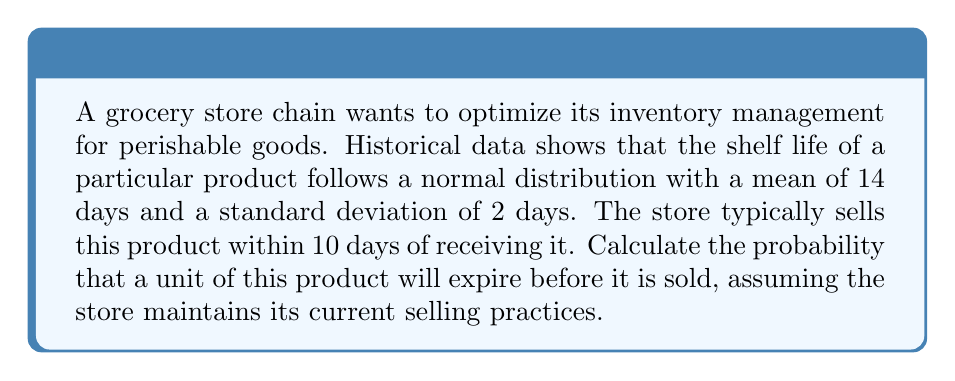Help me with this question. Let's approach this step-by-step:

1) Let X be the random variable representing the shelf life of the product in days.
   X ~ N(μ = 14, σ = 2)

2) We need to find P(X ≤ 10), the probability that the shelf life is 10 days or less.

3) To do this, we need to calculate the z-score for 10 days:

   $$ z = \frac{x - \mu}{\sigma} = \frac{10 - 14}{2} = -2 $$

4) Now we need to find the probability that Z ≤ -2 using the standard normal distribution table.

5) From the table, we find that P(Z ≤ -2) ≈ 0.0228

6) Therefore, the probability that a unit of this product will expire before it is sold is approximately 0.0228 or 2.28%.

This low probability suggests that the current inventory management is relatively efficient. However, the store could potentially extend the selling window to reduce waste further and maximize profits, albeit at the risk of slightly increased spoilage.
Answer: 0.0228 or 2.28% 